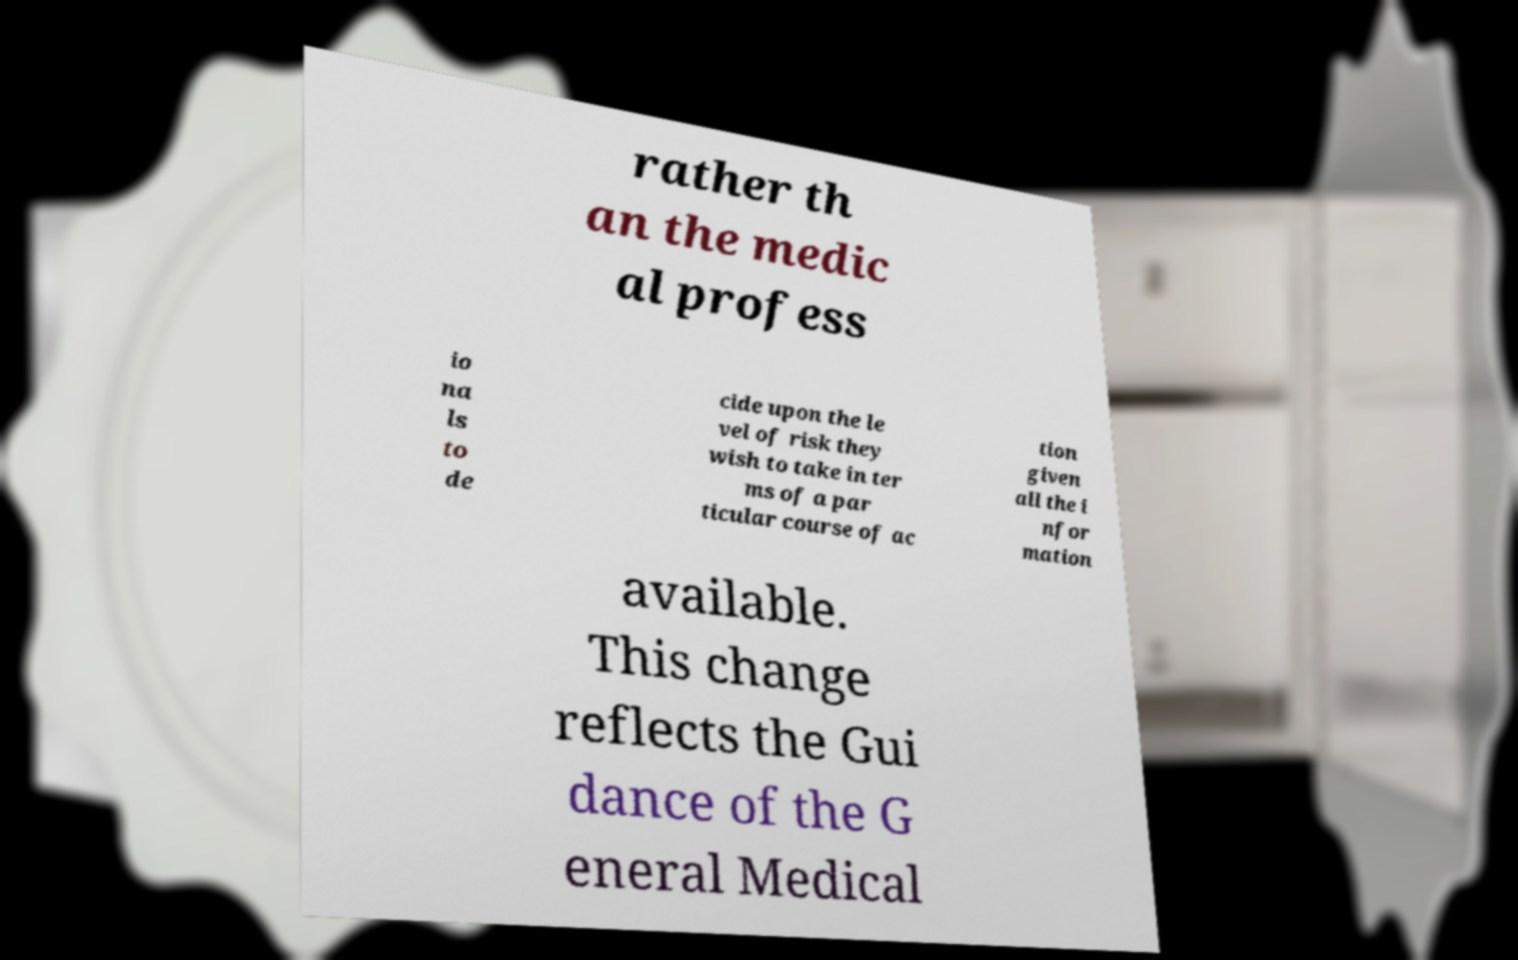Can you read and provide the text displayed in the image?This photo seems to have some interesting text. Can you extract and type it out for me? rather th an the medic al profess io na ls to de cide upon the le vel of risk they wish to take in ter ms of a par ticular course of ac tion given all the i nfor mation available. This change reflects the Gui dance of the G eneral Medical 